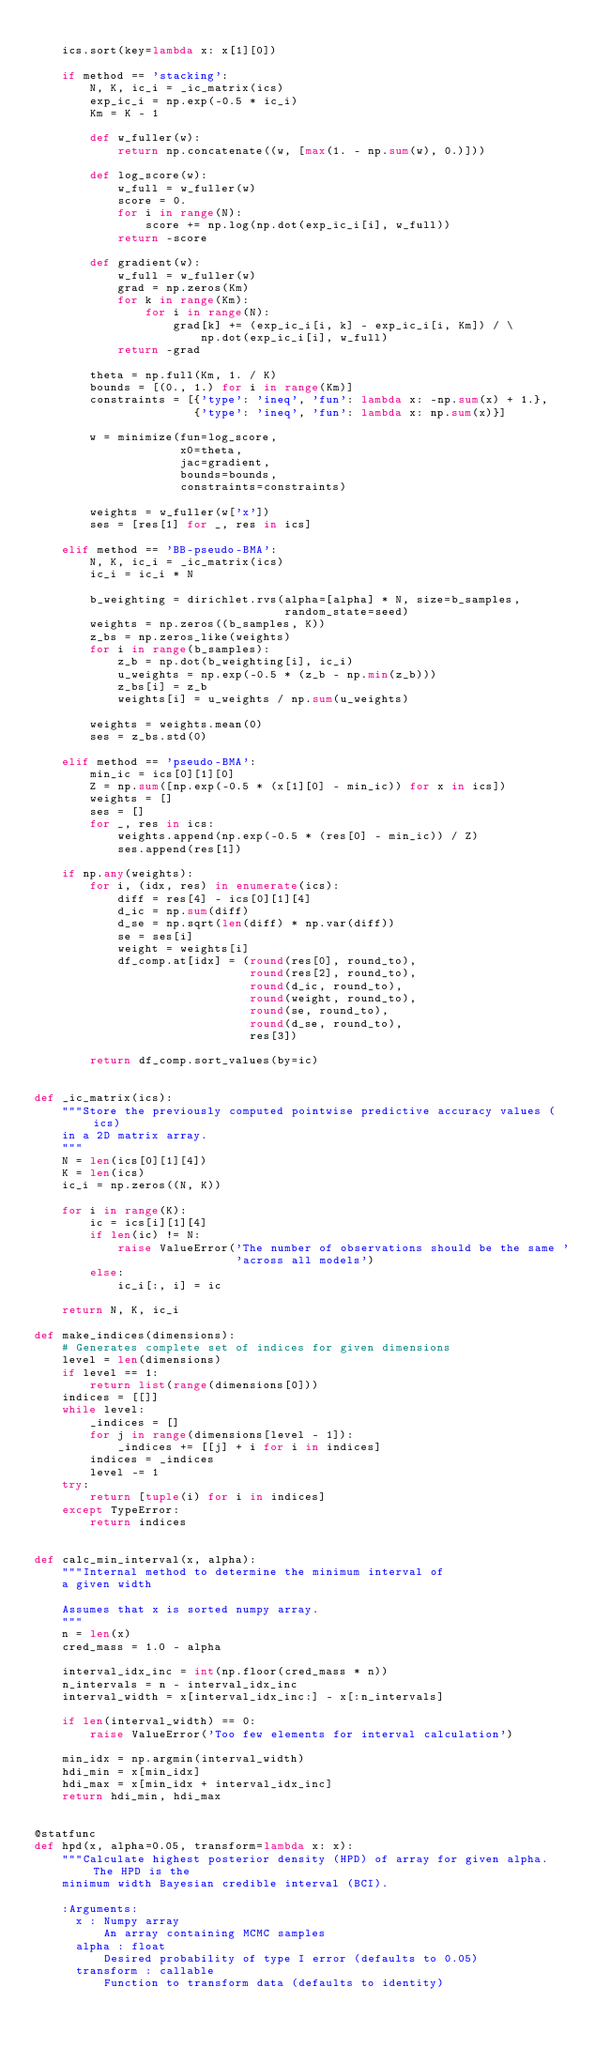Convert code to text. <code><loc_0><loc_0><loc_500><loc_500><_Python_>
    ics.sort(key=lambda x: x[1][0])

    if method == 'stacking':
        N, K, ic_i = _ic_matrix(ics)
        exp_ic_i = np.exp(-0.5 * ic_i)
        Km = K - 1

        def w_fuller(w):
            return np.concatenate((w, [max(1. - np.sum(w), 0.)]))

        def log_score(w):
            w_full = w_fuller(w)
            score = 0.
            for i in range(N):
                score += np.log(np.dot(exp_ic_i[i], w_full))
            return -score

        def gradient(w):
            w_full = w_fuller(w)
            grad = np.zeros(Km)
            for k in range(Km):
                for i in range(N):
                    grad[k] += (exp_ic_i[i, k] - exp_ic_i[i, Km]) / \
                        np.dot(exp_ic_i[i], w_full)
            return -grad

        theta = np.full(Km, 1. / K)
        bounds = [(0., 1.) for i in range(Km)]
        constraints = [{'type': 'ineq', 'fun': lambda x: -np.sum(x) + 1.},
                       {'type': 'ineq', 'fun': lambda x: np.sum(x)}]

        w = minimize(fun=log_score,
                     x0=theta,
                     jac=gradient,
                     bounds=bounds,
                     constraints=constraints)

        weights = w_fuller(w['x'])
        ses = [res[1] for _, res in ics]

    elif method == 'BB-pseudo-BMA':
        N, K, ic_i = _ic_matrix(ics)
        ic_i = ic_i * N

        b_weighting = dirichlet.rvs(alpha=[alpha] * N, size=b_samples,
                                    random_state=seed)
        weights = np.zeros((b_samples, K))
        z_bs = np.zeros_like(weights)
        for i in range(b_samples):
            z_b = np.dot(b_weighting[i], ic_i)
            u_weights = np.exp(-0.5 * (z_b - np.min(z_b)))
            z_bs[i] = z_b
            weights[i] = u_weights / np.sum(u_weights)

        weights = weights.mean(0)
        ses = z_bs.std(0)

    elif method == 'pseudo-BMA':
        min_ic = ics[0][1][0]
        Z = np.sum([np.exp(-0.5 * (x[1][0] - min_ic)) for x in ics])
        weights = []
        ses = []
        for _, res in ics:
            weights.append(np.exp(-0.5 * (res[0] - min_ic)) / Z)
            ses.append(res[1])

    if np.any(weights):
        for i, (idx, res) in enumerate(ics):
            diff = res[4] - ics[0][1][4]
            d_ic = np.sum(diff)
            d_se = np.sqrt(len(diff) * np.var(diff))
            se = ses[i]
            weight = weights[i]
            df_comp.at[idx] = (round(res[0], round_to),
                               round(res[2], round_to),
                               round(d_ic, round_to),
                               round(weight, round_to),
                               round(se, round_to),
                               round(d_se, round_to),
                               res[3])

        return df_comp.sort_values(by=ic)


def _ic_matrix(ics):
    """Store the previously computed pointwise predictive accuracy values (ics)
    in a 2D matrix array.
    """
    N = len(ics[0][1][4])
    K = len(ics)
    ic_i = np.zeros((N, K))

    for i in range(K):
        ic = ics[i][1][4]
        if len(ic) != N:
            raise ValueError('The number of observations should be the same '
                             'across all models')
        else:
            ic_i[:, i] = ic

    return N, K, ic_i

def make_indices(dimensions):
    # Generates complete set of indices for given dimensions
    level = len(dimensions)
    if level == 1:
        return list(range(dimensions[0]))
    indices = [[]]
    while level:
        _indices = []
        for j in range(dimensions[level - 1]):
            _indices += [[j] + i for i in indices]
        indices = _indices
        level -= 1
    try:
        return [tuple(i) for i in indices]
    except TypeError:
        return indices


def calc_min_interval(x, alpha):
    """Internal method to determine the minimum interval of
    a given width

    Assumes that x is sorted numpy array.
    """
    n = len(x)
    cred_mass = 1.0 - alpha

    interval_idx_inc = int(np.floor(cred_mass * n))
    n_intervals = n - interval_idx_inc
    interval_width = x[interval_idx_inc:] - x[:n_intervals]

    if len(interval_width) == 0:
        raise ValueError('Too few elements for interval calculation')

    min_idx = np.argmin(interval_width)
    hdi_min = x[min_idx]
    hdi_max = x[min_idx + interval_idx_inc]
    return hdi_min, hdi_max


@statfunc
def hpd(x, alpha=0.05, transform=lambda x: x):
    """Calculate highest posterior density (HPD) of array for given alpha. The HPD is the
    minimum width Bayesian credible interval (BCI).

    :Arguments:
      x : Numpy array
          An array containing MCMC samples
      alpha : float
          Desired probability of type I error (defaults to 0.05)
      transform : callable
          Function to transform data (defaults to identity)
</code> 